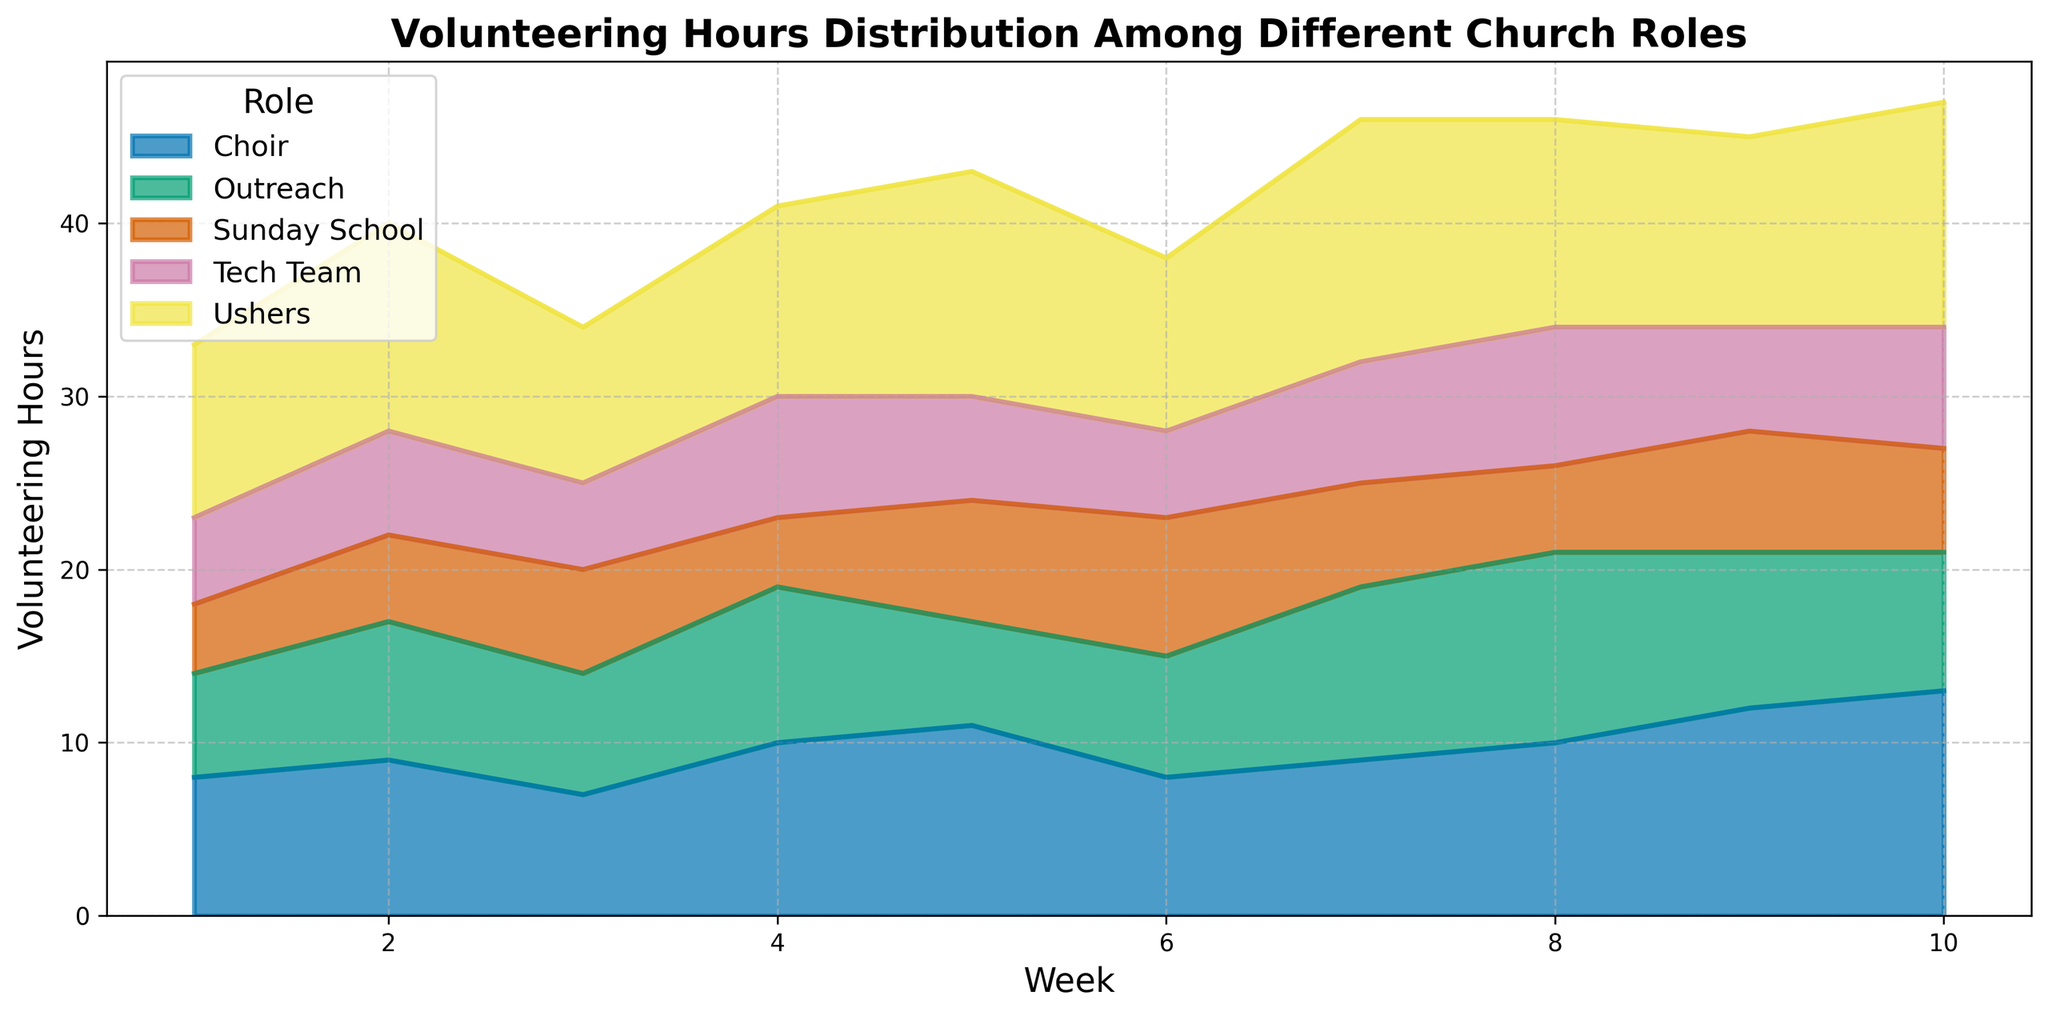What is the total number of volunteering hours for Ushers over the 10 weeks? To find the total number of volunteering hours for Ushers, sum up the hours for each week: 10 + 12 + 9 + 11 + 13 + 10 + 14 + 12 + 11 + 13 = 115
Answer: 115 Which role had the highest number of volunteering hours in Week 10? From the figure, observe the height of the areas at Week 10, comparing all roles. Choir with 13 hours had the highest value.
Answer: Choir In which week did the Outreach role have the highest number of volunteering hours? Look across the weeks for the Outreach area and identify the week with the highest peak, which is Week 8 with 11 hours.
Answer: Week 8 What is the average number of volunteering hours for the Tech Team over the 10 weeks? Sum the hours for the Tech Team over 10 weeks: 5 + 6 + 5 + 7 + 6 + 5 + 7 + 8 + 6 + 7 = 62 and then divide by 10 weeks: 62/10 = 6.2
Answer: 6.2 Which role consistently showed the lowest number of volunteering hours? Compare the overall area heights for each role, the Tech Team consistently shows the lowest number of hours across the weeks.
Answer: Tech Team By how much did the total volunteering hours for Choir differ from the total volunteering hours for Sunday School? Sum the hours for Choir: 8 + 9 + 7 + 10 + 11 + 8 + 9 + 10 + 12 + 13 = 97 and for Sunday School: 4 + 5 + 6 + 4 + 7 + 8 + 6 + 5 + 7 + 6 = 58. Then, find the difference: 97 - 58 = 39
Answer: 39 In Week 6, which role had more volunteering hours, Tech Team or Outreach? And by how many hours? Compare the areas at Week 6 for Tech Team (5 hours) and Outreach (7 hours). Outreach had more hours. The difference is 7 - 5 = 2 hours.
Answer: Outreach, 2 hours What is the trend of volunteering hours for Ushers from Week 1 to Week 10? Observe the Ushers area over the weeks. The trend shows fluctuations with a slight overall increase, starting from 10 hours in Week 1 to 13 hours in Week 10.
Answer: Fluctuates with slight increase If you combine the hours of Choir and Outreach in Week 5, how does it compare to Ushers? Add hours for Choir and Outreach in Week 5: Choir (11) + Outreach (6) = 17. Compare this to Ushers: 13. So, combined hours are more than Ushers by 17 - 13 = 4 hours.
Answer: More by 4 hours Which weeks show a peak in volunteering hours for Sunday School? Identify the highest points in the Sunday School area, notably in Weeks 6 and 9 with peaks at 8 and 7 hours respectively.
Answer: Weeks 6 and 9 